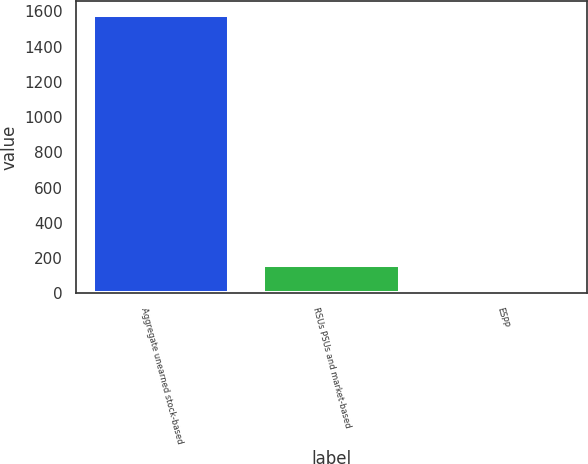<chart> <loc_0><loc_0><loc_500><loc_500><bar_chart><fcel>Aggregate unearned stock-based<fcel>RSUs PSUs and market-based<fcel>ESPP<nl><fcel>1580<fcel>158.72<fcel>0.8<nl></chart> 